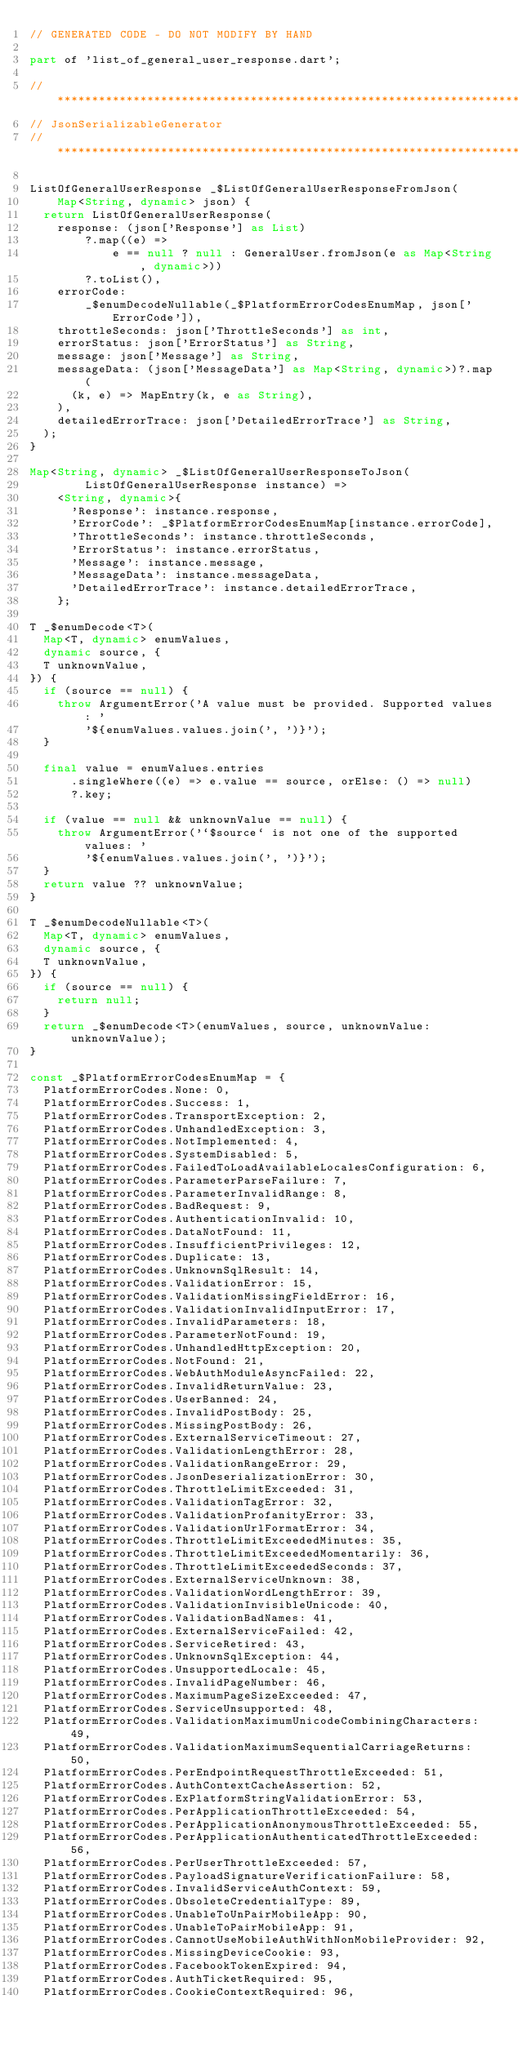<code> <loc_0><loc_0><loc_500><loc_500><_Dart_>// GENERATED CODE - DO NOT MODIFY BY HAND

part of 'list_of_general_user_response.dart';

// **************************************************************************
// JsonSerializableGenerator
// **************************************************************************

ListOfGeneralUserResponse _$ListOfGeneralUserResponseFromJson(
    Map<String, dynamic> json) {
  return ListOfGeneralUserResponse(
    response: (json['Response'] as List)
        ?.map((e) =>
            e == null ? null : GeneralUser.fromJson(e as Map<String, dynamic>))
        ?.toList(),
    errorCode:
        _$enumDecodeNullable(_$PlatformErrorCodesEnumMap, json['ErrorCode']),
    throttleSeconds: json['ThrottleSeconds'] as int,
    errorStatus: json['ErrorStatus'] as String,
    message: json['Message'] as String,
    messageData: (json['MessageData'] as Map<String, dynamic>)?.map(
      (k, e) => MapEntry(k, e as String),
    ),
    detailedErrorTrace: json['DetailedErrorTrace'] as String,
  );
}

Map<String, dynamic> _$ListOfGeneralUserResponseToJson(
        ListOfGeneralUserResponse instance) =>
    <String, dynamic>{
      'Response': instance.response,
      'ErrorCode': _$PlatformErrorCodesEnumMap[instance.errorCode],
      'ThrottleSeconds': instance.throttleSeconds,
      'ErrorStatus': instance.errorStatus,
      'Message': instance.message,
      'MessageData': instance.messageData,
      'DetailedErrorTrace': instance.detailedErrorTrace,
    };

T _$enumDecode<T>(
  Map<T, dynamic> enumValues,
  dynamic source, {
  T unknownValue,
}) {
  if (source == null) {
    throw ArgumentError('A value must be provided. Supported values: '
        '${enumValues.values.join(', ')}');
  }

  final value = enumValues.entries
      .singleWhere((e) => e.value == source, orElse: () => null)
      ?.key;

  if (value == null && unknownValue == null) {
    throw ArgumentError('`$source` is not one of the supported values: '
        '${enumValues.values.join(', ')}');
  }
  return value ?? unknownValue;
}

T _$enumDecodeNullable<T>(
  Map<T, dynamic> enumValues,
  dynamic source, {
  T unknownValue,
}) {
  if (source == null) {
    return null;
  }
  return _$enumDecode<T>(enumValues, source, unknownValue: unknownValue);
}

const _$PlatformErrorCodesEnumMap = {
  PlatformErrorCodes.None: 0,
  PlatformErrorCodes.Success: 1,
  PlatformErrorCodes.TransportException: 2,
  PlatformErrorCodes.UnhandledException: 3,
  PlatformErrorCodes.NotImplemented: 4,
  PlatformErrorCodes.SystemDisabled: 5,
  PlatformErrorCodes.FailedToLoadAvailableLocalesConfiguration: 6,
  PlatformErrorCodes.ParameterParseFailure: 7,
  PlatformErrorCodes.ParameterInvalidRange: 8,
  PlatformErrorCodes.BadRequest: 9,
  PlatformErrorCodes.AuthenticationInvalid: 10,
  PlatformErrorCodes.DataNotFound: 11,
  PlatformErrorCodes.InsufficientPrivileges: 12,
  PlatformErrorCodes.Duplicate: 13,
  PlatformErrorCodes.UnknownSqlResult: 14,
  PlatformErrorCodes.ValidationError: 15,
  PlatformErrorCodes.ValidationMissingFieldError: 16,
  PlatformErrorCodes.ValidationInvalidInputError: 17,
  PlatformErrorCodes.InvalidParameters: 18,
  PlatformErrorCodes.ParameterNotFound: 19,
  PlatformErrorCodes.UnhandledHttpException: 20,
  PlatformErrorCodes.NotFound: 21,
  PlatformErrorCodes.WebAuthModuleAsyncFailed: 22,
  PlatformErrorCodes.InvalidReturnValue: 23,
  PlatformErrorCodes.UserBanned: 24,
  PlatformErrorCodes.InvalidPostBody: 25,
  PlatformErrorCodes.MissingPostBody: 26,
  PlatformErrorCodes.ExternalServiceTimeout: 27,
  PlatformErrorCodes.ValidationLengthError: 28,
  PlatformErrorCodes.ValidationRangeError: 29,
  PlatformErrorCodes.JsonDeserializationError: 30,
  PlatformErrorCodes.ThrottleLimitExceeded: 31,
  PlatformErrorCodes.ValidationTagError: 32,
  PlatformErrorCodes.ValidationProfanityError: 33,
  PlatformErrorCodes.ValidationUrlFormatError: 34,
  PlatformErrorCodes.ThrottleLimitExceededMinutes: 35,
  PlatformErrorCodes.ThrottleLimitExceededMomentarily: 36,
  PlatformErrorCodes.ThrottleLimitExceededSeconds: 37,
  PlatformErrorCodes.ExternalServiceUnknown: 38,
  PlatformErrorCodes.ValidationWordLengthError: 39,
  PlatformErrorCodes.ValidationInvisibleUnicode: 40,
  PlatformErrorCodes.ValidationBadNames: 41,
  PlatformErrorCodes.ExternalServiceFailed: 42,
  PlatformErrorCodes.ServiceRetired: 43,
  PlatformErrorCodes.UnknownSqlException: 44,
  PlatformErrorCodes.UnsupportedLocale: 45,
  PlatformErrorCodes.InvalidPageNumber: 46,
  PlatformErrorCodes.MaximumPageSizeExceeded: 47,
  PlatformErrorCodes.ServiceUnsupported: 48,
  PlatformErrorCodes.ValidationMaximumUnicodeCombiningCharacters: 49,
  PlatformErrorCodes.ValidationMaximumSequentialCarriageReturns: 50,
  PlatformErrorCodes.PerEndpointRequestThrottleExceeded: 51,
  PlatformErrorCodes.AuthContextCacheAssertion: 52,
  PlatformErrorCodes.ExPlatformStringValidationError: 53,
  PlatformErrorCodes.PerApplicationThrottleExceeded: 54,
  PlatformErrorCodes.PerApplicationAnonymousThrottleExceeded: 55,
  PlatformErrorCodes.PerApplicationAuthenticatedThrottleExceeded: 56,
  PlatformErrorCodes.PerUserThrottleExceeded: 57,
  PlatformErrorCodes.PayloadSignatureVerificationFailure: 58,
  PlatformErrorCodes.InvalidServiceAuthContext: 59,
  PlatformErrorCodes.ObsoleteCredentialType: 89,
  PlatformErrorCodes.UnableToUnPairMobileApp: 90,
  PlatformErrorCodes.UnableToPairMobileApp: 91,
  PlatformErrorCodes.CannotUseMobileAuthWithNonMobileProvider: 92,
  PlatformErrorCodes.MissingDeviceCookie: 93,
  PlatformErrorCodes.FacebookTokenExpired: 94,
  PlatformErrorCodes.AuthTicketRequired: 95,
  PlatformErrorCodes.CookieContextRequired: 96,</code> 